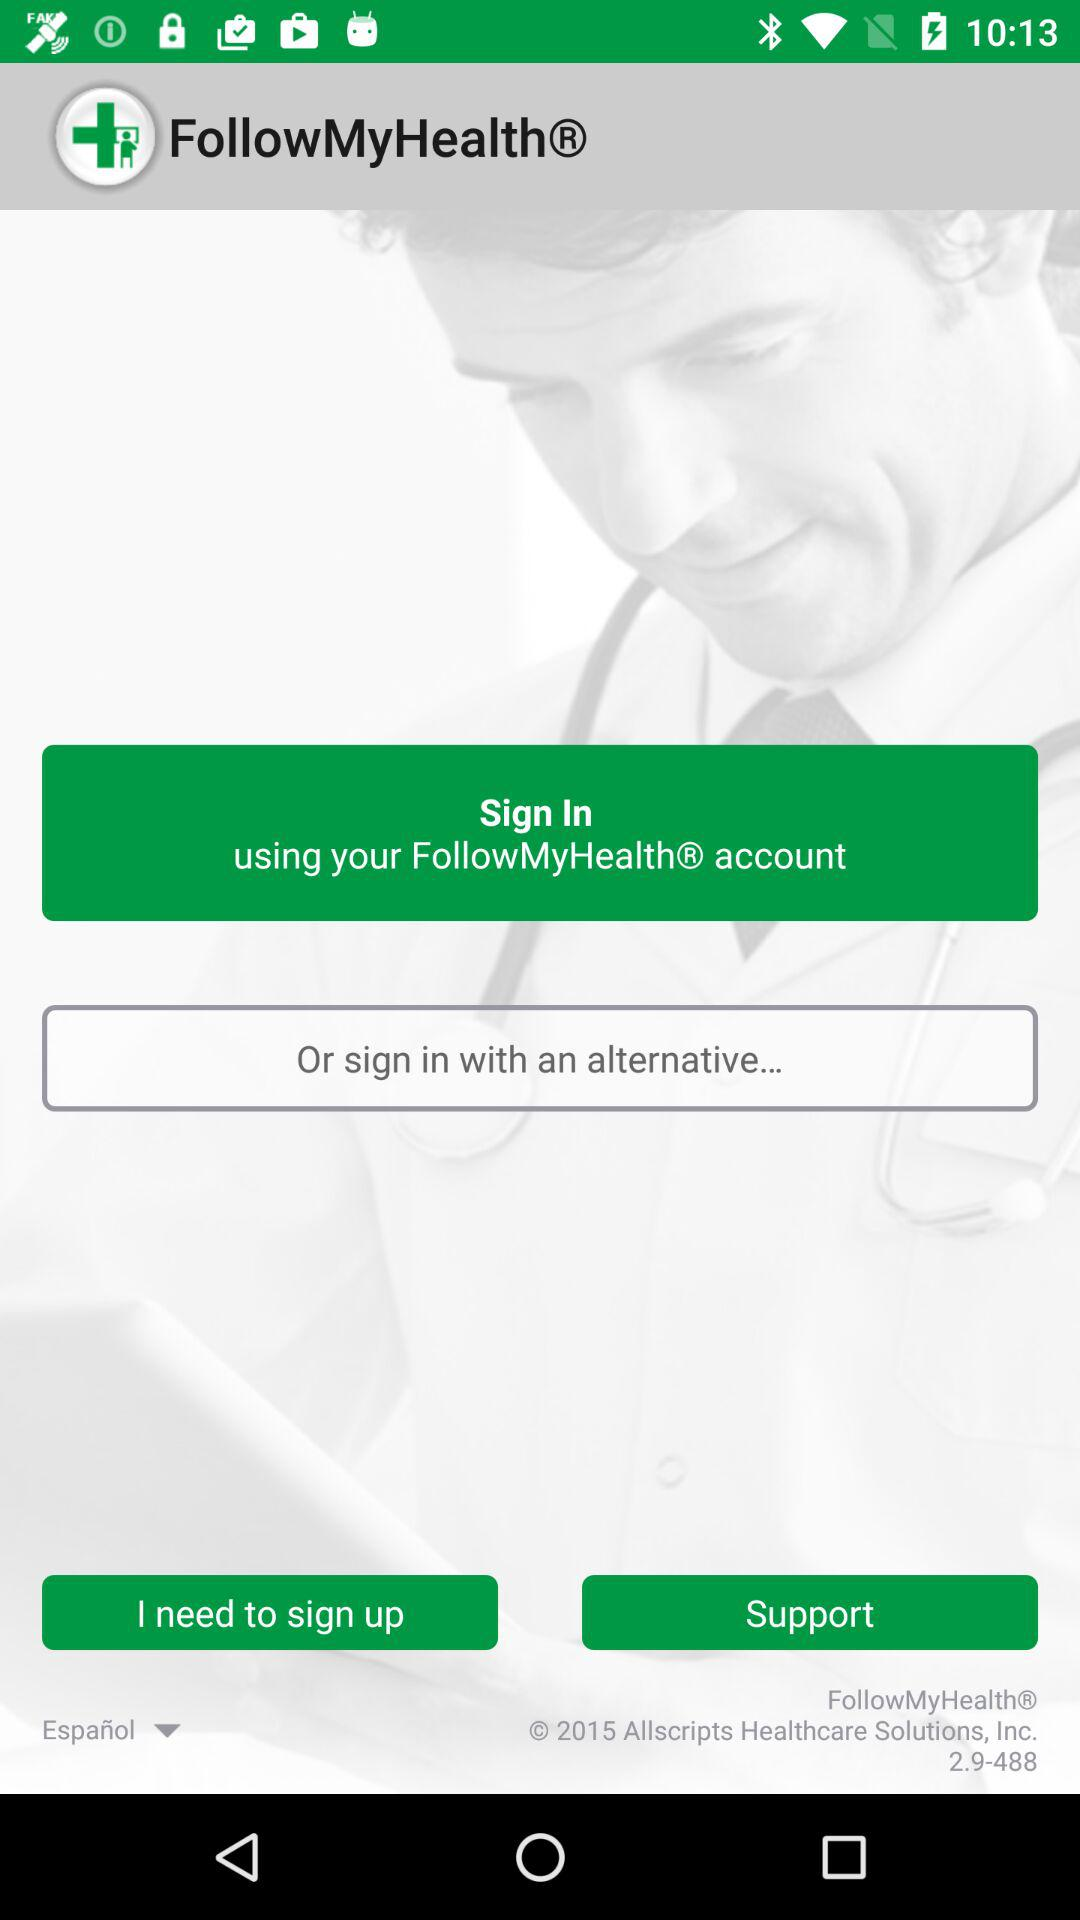What is the name of the application? The name of the application is "FollowMyHealth". 